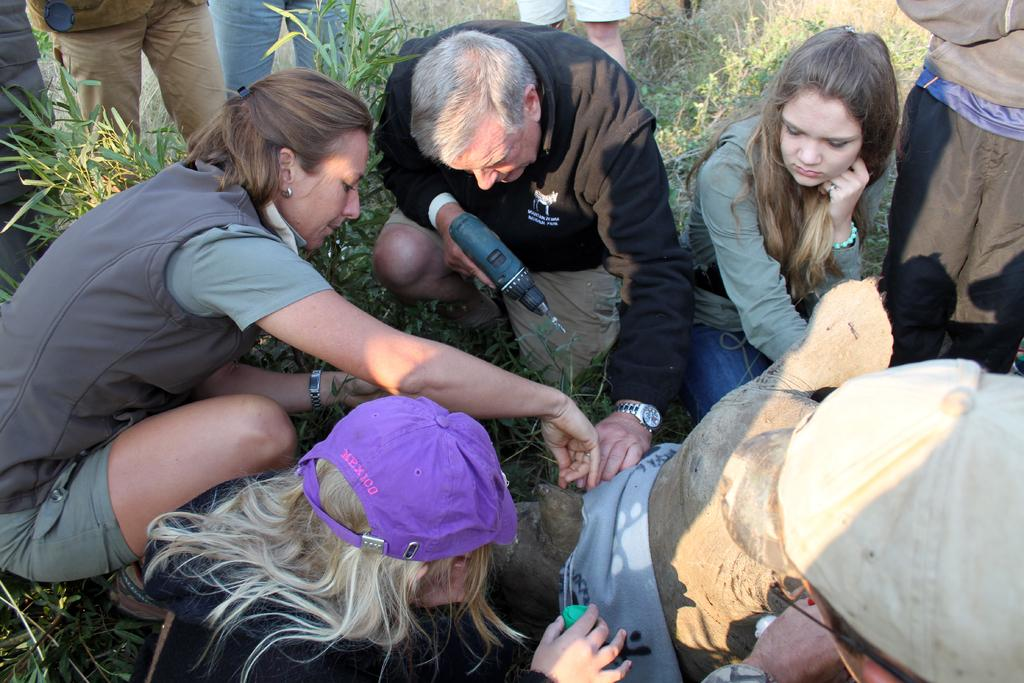How many people are in the image? There are people in the image. What is the man in the middle doing? The man in the middle is holding a drill machine. What can be seen at the bottom of the image? There are plants at the bottom of the image. What are the two persons at the bottom wearing? The two persons at the bottom are wearing caps. What type of magic is being performed with the drill machine in the image? There is no magic being performed in the image; the man is simply holding a drill machine. Can you see any sleet falling in the image? There is no mention of sleet or any weather condition in the image; it only shows people, a drill machine, and plants. 